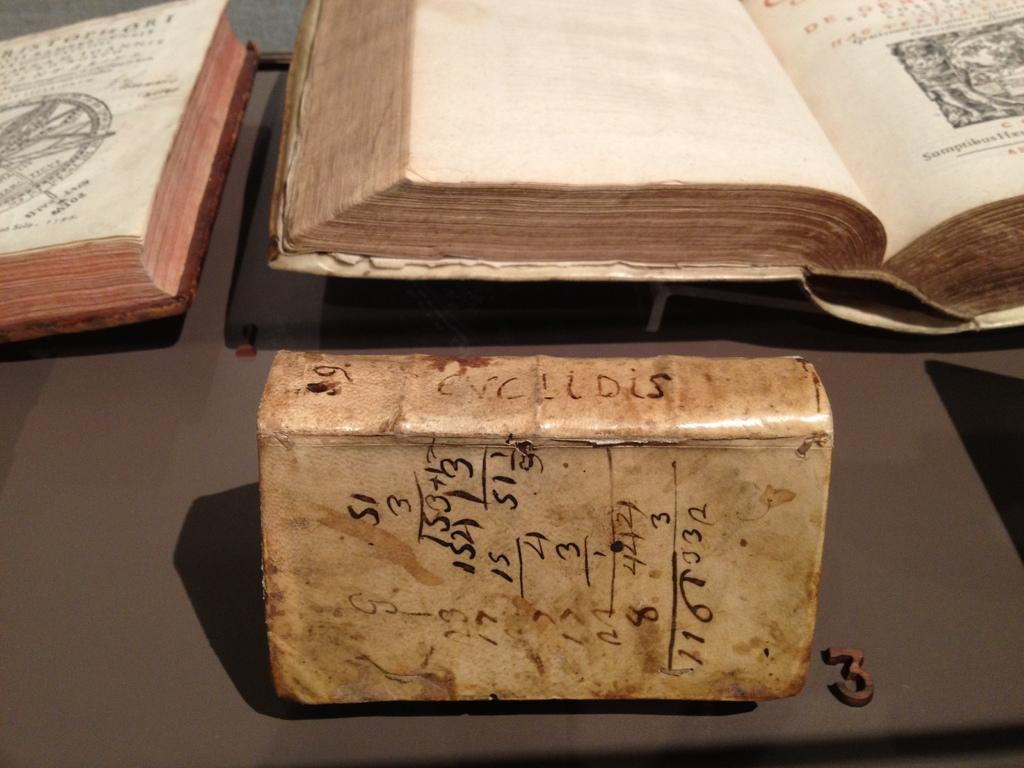<image>
Share a concise interpretation of the image provided. A very old leather bound book with the letters "Enclidis" on the spine. 